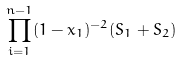Convert formula to latex. <formula><loc_0><loc_0><loc_500><loc_500>\prod _ { i = 1 } ^ { n - 1 } ( 1 - x _ { 1 } ) ^ { - 2 } ( S _ { 1 } + S _ { 2 } )</formula> 